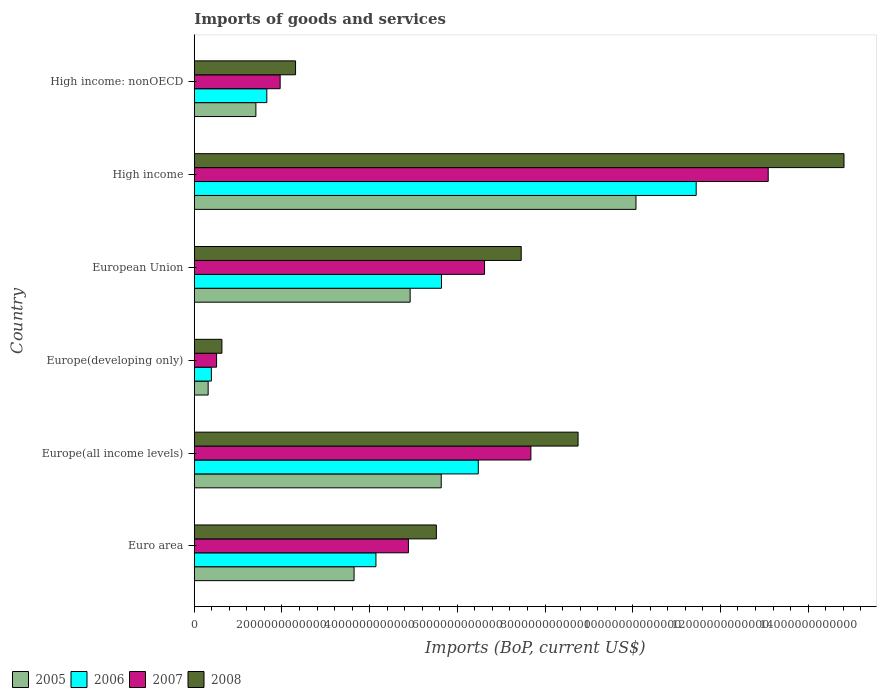Are the number of bars per tick equal to the number of legend labels?
Ensure brevity in your answer.  Yes. How many bars are there on the 1st tick from the top?
Provide a succinct answer. 4. What is the label of the 2nd group of bars from the top?
Offer a very short reply. High income. What is the amount spent on imports in 2007 in Europe(developing only)?
Offer a terse response. 5.09e+11. Across all countries, what is the maximum amount spent on imports in 2006?
Provide a short and direct response. 1.14e+13. Across all countries, what is the minimum amount spent on imports in 2006?
Offer a very short reply. 3.90e+11. In which country was the amount spent on imports in 2007 maximum?
Provide a succinct answer. High income. In which country was the amount spent on imports in 2008 minimum?
Provide a succinct answer. Europe(developing only). What is the total amount spent on imports in 2005 in the graph?
Your answer should be very brief. 2.60e+13. What is the difference between the amount spent on imports in 2006 in Euro area and that in Europe(all income levels)?
Ensure brevity in your answer.  -2.33e+12. What is the difference between the amount spent on imports in 2007 in Euro area and the amount spent on imports in 2008 in High income: nonOECD?
Keep it short and to the point. 2.57e+12. What is the average amount spent on imports in 2007 per country?
Offer a terse response. 5.79e+12. What is the difference between the amount spent on imports in 2005 and amount spent on imports in 2006 in Europe(all income levels)?
Your answer should be very brief. -8.45e+11. In how many countries, is the amount spent on imports in 2006 greater than 13200000000000 US$?
Give a very brief answer. 0. What is the ratio of the amount spent on imports in 2008 in Euro area to that in Europe(all income levels)?
Provide a short and direct response. 0.63. Is the difference between the amount spent on imports in 2005 in Europe(all income levels) and European Union greater than the difference between the amount spent on imports in 2006 in Europe(all income levels) and European Union?
Offer a very short reply. No. What is the difference between the highest and the second highest amount spent on imports in 2006?
Offer a very short reply. 4.97e+12. What is the difference between the highest and the lowest amount spent on imports in 2008?
Make the answer very short. 1.42e+13. In how many countries, is the amount spent on imports in 2007 greater than the average amount spent on imports in 2007 taken over all countries?
Provide a short and direct response. 3. Is the sum of the amount spent on imports in 2006 in Europe(all income levels) and High income greater than the maximum amount spent on imports in 2008 across all countries?
Provide a short and direct response. Yes. How many bars are there?
Offer a terse response. 24. What is the difference between two consecutive major ticks on the X-axis?
Offer a very short reply. 2.00e+12. Does the graph contain any zero values?
Keep it short and to the point. No. Where does the legend appear in the graph?
Provide a succinct answer. Bottom left. How many legend labels are there?
Keep it short and to the point. 4. How are the legend labels stacked?
Keep it short and to the point. Horizontal. What is the title of the graph?
Your answer should be very brief. Imports of goods and services. Does "2007" appear as one of the legend labels in the graph?
Provide a succinct answer. Yes. What is the label or title of the X-axis?
Provide a succinct answer. Imports (BoP, current US$). What is the Imports (BoP, current US$) in 2005 in Euro area?
Make the answer very short. 3.64e+12. What is the Imports (BoP, current US$) in 2006 in Euro area?
Give a very brief answer. 4.14e+12. What is the Imports (BoP, current US$) of 2007 in Euro area?
Your answer should be compact. 4.88e+12. What is the Imports (BoP, current US$) in 2008 in Euro area?
Offer a terse response. 5.52e+12. What is the Imports (BoP, current US$) of 2005 in Europe(all income levels)?
Offer a very short reply. 5.63e+12. What is the Imports (BoP, current US$) of 2006 in Europe(all income levels)?
Your answer should be very brief. 6.48e+12. What is the Imports (BoP, current US$) of 2007 in Europe(all income levels)?
Give a very brief answer. 7.68e+12. What is the Imports (BoP, current US$) in 2008 in Europe(all income levels)?
Your answer should be very brief. 8.75e+12. What is the Imports (BoP, current US$) of 2005 in Europe(developing only)?
Provide a short and direct response. 3.17e+11. What is the Imports (BoP, current US$) in 2006 in Europe(developing only)?
Provide a succinct answer. 3.90e+11. What is the Imports (BoP, current US$) in 2007 in Europe(developing only)?
Provide a short and direct response. 5.09e+11. What is the Imports (BoP, current US$) in 2008 in Europe(developing only)?
Keep it short and to the point. 6.31e+11. What is the Imports (BoP, current US$) in 2005 in European Union?
Keep it short and to the point. 4.92e+12. What is the Imports (BoP, current US$) of 2006 in European Union?
Give a very brief answer. 5.64e+12. What is the Imports (BoP, current US$) in 2007 in European Union?
Your answer should be very brief. 6.62e+12. What is the Imports (BoP, current US$) of 2008 in European Union?
Keep it short and to the point. 7.46e+12. What is the Imports (BoP, current US$) in 2005 in High income?
Make the answer very short. 1.01e+13. What is the Imports (BoP, current US$) in 2006 in High income?
Ensure brevity in your answer.  1.14e+13. What is the Imports (BoP, current US$) of 2007 in High income?
Your answer should be compact. 1.31e+13. What is the Imports (BoP, current US$) of 2008 in High income?
Offer a very short reply. 1.48e+13. What is the Imports (BoP, current US$) in 2005 in High income: nonOECD?
Provide a succinct answer. 1.41e+12. What is the Imports (BoP, current US$) of 2006 in High income: nonOECD?
Offer a very short reply. 1.65e+12. What is the Imports (BoP, current US$) in 2007 in High income: nonOECD?
Offer a very short reply. 1.96e+12. What is the Imports (BoP, current US$) in 2008 in High income: nonOECD?
Your answer should be very brief. 2.31e+12. Across all countries, what is the maximum Imports (BoP, current US$) in 2005?
Your answer should be very brief. 1.01e+13. Across all countries, what is the maximum Imports (BoP, current US$) of 2006?
Your response must be concise. 1.14e+13. Across all countries, what is the maximum Imports (BoP, current US$) of 2007?
Provide a succinct answer. 1.31e+13. Across all countries, what is the maximum Imports (BoP, current US$) of 2008?
Make the answer very short. 1.48e+13. Across all countries, what is the minimum Imports (BoP, current US$) in 2005?
Keep it short and to the point. 3.17e+11. Across all countries, what is the minimum Imports (BoP, current US$) of 2006?
Give a very brief answer. 3.90e+11. Across all countries, what is the minimum Imports (BoP, current US$) of 2007?
Offer a very short reply. 5.09e+11. Across all countries, what is the minimum Imports (BoP, current US$) in 2008?
Offer a very short reply. 6.31e+11. What is the total Imports (BoP, current US$) in 2005 in the graph?
Offer a terse response. 2.60e+13. What is the total Imports (BoP, current US$) in 2006 in the graph?
Ensure brevity in your answer.  2.97e+13. What is the total Imports (BoP, current US$) in 2007 in the graph?
Ensure brevity in your answer.  3.47e+13. What is the total Imports (BoP, current US$) in 2008 in the graph?
Give a very brief answer. 3.95e+13. What is the difference between the Imports (BoP, current US$) in 2005 in Euro area and that in Europe(all income levels)?
Your answer should be very brief. -1.99e+12. What is the difference between the Imports (BoP, current US$) in 2006 in Euro area and that in Europe(all income levels)?
Offer a terse response. -2.33e+12. What is the difference between the Imports (BoP, current US$) of 2007 in Euro area and that in Europe(all income levels)?
Provide a succinct answer. -2.79e+12. What is the difference between the Imports (BoP, current US$) of 2008 in Euro area and that in Europe(all income levels)?
Keep it short and to the point. -3.23e+12. What is the difference between the Imports (BoP, current US$) of 2005 in Euro area and that in Europe(developing only)?
Offer a very short reply. 3.33e+12. What is the difference between the Imports (BoP, current US$) of 2006 in Euro area and that in Europe(developing only)?
Keep it short and to the point. 3.75e+12. What is the difference between the Imports (BoP, current US$) of 2007 in Euro area and that in Europe(developing only)?
Your answer should be very brief. 4.38e+12. What is the difference between the Imports (BoP, current US$) in 2008 in Euro area and that in Europe(developing only)?
Provide a succinct answer. 4.89e+12. What is the difference between the Imports (BoP, current US$) of 2005 in Euro area and that in European Union?
Make the answer very short. -1.28e+12. What is the difference between the Imports (BoP, current US$) of 2006 in Euro area and that in European Union?
Your response must be concise. -1.49e+12. What is the difference between the Imports (BoP, current US$) in 2007 in Euro area and that in European Union?
Give a very brief answer. -1.74e+12. What is the difference between the Imports (BoP, current US$) in 2008 in Euro area and that in European Union?
Make the answer very short. -1.94e+12. What is the difference between the Imports (BoP, current US$) of 2005 in Euro area and that in High income?
Provide a succinct answer. -6.43e+12. What is the difference between the Imports (BoP, current US$) of 2006 in Euro area and that in High income?
Provide a short and direct response. -7.30e+12. What is the difference between the Imports (BoP, current US$) in 2007 in Euro area and that in High income?
Your answer should be very brief. -8.21e+12. What is the difference between the Imports (BoP, current US$) in 2008 in Euro area and that in High income?
Your answer should be very brief. -9.30e+12. What is the difference between the Imports (BoP, current US$) in 2005 in Euro area and that in High income: nonOECD?
Your response must be concise. 2.24e+12. What is the difference between the Imports (BoP, current US$) of 2006 in Euro area and that in High income: nonOECD?
Your response must be concise. 2.49e+12. What is the difference between the Imports (BoP, current US$) in 2007 in Euro area and that in High income: nonOECD?
Make the answer very short. 2.93e+12. What is the difference between the Imports (BoP, current US$) in 2008 in Euro area and that in High income: nonOECD?
Ensure brevity in your answer.  3.21e+12. What is the difference between the Imports (BoP, current US$) in 2005 in Europe(all income levels) and that in Europe(developing only)?
Your response must be concise. 5.32e+12. What is the difference between the Imports (BoP, current US$) in 2006 in Europe(all income levels) and that in Europe(developing only)?
Ensure brevity in your answer.  6.09e+12. What is the difference between the Imports (BoP, current US$) in 2007 in Europe(all income levels) and that in Europe(developing only)?
Offer a terse response. 7.17e+12. What is the difference between the Imports (BoP, current US$) of 2008 in Europe(all income levels) and that in Europe(developing only)?
Offer a very short reply. 8.12e+12. What is the difference between the Imports (BoP, current US$) of 2005 in Europe(all income levels) and that in European Union?
Offer a very short reply. 7.09e+11. What is the difference between the Imports (BoP, current US$) of 2006 in Europe(all income levels) and that in European Union?
Your answer should be compact. 8.39e+11. What is the difference between the Imports (BoP, current US$) of 2007 in Europe(all income levels) and that in European Union?
Provide a succinct answer. 1.06e+12. What is the difference between the Imports (BoP, current US$) of 2008 in Europe(all income levels) and that in European Union?
Offer a very short reply. 1.30e+12. What is the difference between the Imports (BoP, current US$) of 2005 in Europe(all income levels) and that in High income?
Provide a succinct answer. -4.44e+12. What is the difference between the Imports (BoP, current US$) of 2006 in Europe(all income levels) and that in High income?
Offer a terse response. -4.97e+12. What is the difference between the Imports (BoP, current US$) in 2007 in Europe(all income levels) and that in High income?
Keep it short and to the point. -5.41e+12. What is the difference between the Imports (BoP, current US$) in 2008 in Europe(all income levels) and that in High income?
Provide a succinct answer. -6.06e+12. What is the difference between the Imports (BoP, current US$) of 2005 in Europe(all income levels) and that in High income: nonOECD?
Offer a terse response. 4.23e+12. What is the difference between the Imports (BoP, current US$) of 2006 in Europe(all income levels) and that in High income: nonOECD?
Ensure brevity in your answer.  4.82e+12. What is the difference between the Imports (BoP, current US$) of 2007 in Europe(all income levels) and that in High income: nonOECD?
Offer a terse response. 5.72e+12. What is the difference between the Imports (BoP, current US$) in 2008 in Europe(all income levels) and that in High income: nonOECD?
Make the answer very short. 6.44e+12. What is the difference between the Imports (BoP, current US$) of 2005 in Europe(developing only) and that in European Union?
Your answer should be very brief. -4.61e+12. What is the difference between the Imports (BoP, current US$) of 2006 in Europe(developing only) and that in European Union?
Your response must be concise. -5.25e+12. What is the difference between the Imports (BoP, current US$) in 2007 in Europe(developing only) and that in European Union?
Ensure brevity in your answer.  -6.11e+12. What is the difference between the Imports (BoP, current US$) in 2008 in Europe(developing only) and that in European Union?
Make the answer very short. -6.83e+12. What is the difference between the Imports (BoP, current US$) in 2005 in Europe(developing only) and that in High income?
Your answer should be very brief. -9.76e+12. What is the difference between the Imports (BoP, current US$) of 2006 in Europe(developing only) and that in High income?
Your answer should be very brief. -1.11e+13. What is the difference between the Imports (BoP, current US$) in 2007 in Europe(developing only) and that in High income?
Make the answer very short. -1.26e+13. What is the difference between the Imports (BoP, current US$) in 2008 in Europe(developing only) and that in High income?
Provide a short and direct response. -1.42e+13. What is the difference between the Imports (BoP, current US$) of 2005 in Europe(developing only) and that in High income: nonOECD?
Your answer should be very brief. -1.09e+12. What is the difference between the Imports (BoP, current US$) of 2006 in Europe(developing only) and that in High income: nonOECD?
Keep it short and to the point. -1.26e+12. What is the difference between the Imports (BoP, current US$) of 2007 in Europe(developing only) and that in High income: nonOECD?
Provide a short and direct response. -1.45e+12. What is the difference between the Imports (BoP, current US$) in 2008 in Europe(developing only) and that in High income: nonOECD?
Ensure brevity in your answer.  -1.68e+12. What is the difference between the Imports (BoP, current US$) of 2005 in European Union and that in High income?
Your answer should be very brief. -5.15e+12. What is the difference between the Imports (BoP, current US$) in 2006 in European Union and that in High income?
Offer a terse response. -5.81e+12. What is the difference between the Imports (BoP, current US$) of 2007 in European Union and that in High income?
Provide a succinct answer. -6.47e+12. What is the difference between the Imports (BoP, current US$) of 2008 in European Union and that in High income?
Offer a terse response. -7.36e+12. What is the difference between the Imports (BoP, current US$) of 2005 in European Union and that in High income: nonOECD?
Offer a terse response. 3.52e+12. What is the difference between the Imports (BoP, current US$) of 2006 in European Union and that in High income: nonOECD?
Make the answer very short. 3.98e+12. What is the difference between the Imports (BoP, current US$) in 2007 in European Union and that in High income: nonOECD?
Make the answer very short. 4.66e+12. What is the difference between the Imports (BoP, current US$) of 2008 in European Union and that in High income: nonOECD?
Keep it short and to the point. 5.15e+12. What is the difference between the Imports (BoP, current US$) of 2005 in High income and that in High income: nonOECD?
Your response must be concise. 8.67e+12. What is the difference between the Imports (BoP, current US$) of 2006 in High income and that in High income: nonOECD?
Ensure brevity in your answer.  9.79e+12. What is the difference between the Imports (BoP, current US$) in 2007 in High income and that in High income: nonOECD?
Your response must be concise. 1.11e+13. What is the difference between the Imports (BoP, current US$) in 2008 in High income and that in High income: nonOECD?
Offer a terse response. 1.25e+13. What is the difference between the Imports (BoP, current US$) of 2005 in Euro area and the Imports (BoP, current US$) of 2006 in Europe(all income levels)?
Give a very brief answer. -2.83e+12. What is the difference between the Imports (BoP, current US$) of 2005 in Euro area and the Imports (BoP, current US$) of 2007 in Europe(all income levels)?
Make the answer very short. -4.03e+12. What is the difference between the Imports (BoP, current US$) of 2005 in Euro area and the Imports (BoP, current US$) of 2008 in Europe(all income levels)?
Your response must be concise. -5.11e+12. What is the difference between the Imports (BoP, current US$) of 2006 in Euro area and the Imports (BoP, current US$) of 2007 in Europe(all income levels)?
Give a very brief answer. -3.53e+12. What is the difference between the Imports (BoP, current US$) of 2006 in Euro area and the Imports (BoP, current US$) of 2008 in Europe(all income levels)?
Offer a very short reply. -4.61e+12. What is the difference between the Imports (BoP, current US$) of 2007 in Euro area and the Imports (BoP, current US$) of 2008 in Europe(all income levels)?
Offer a very short reply. -3.87e+12. What is the difference between the Imports (BoP, current US$) in 2005 in Euro area and the Imports (BoP, current US$) in 2006 in Europe(developing only)?
Keep it short and to the point. 3.25e+12. What is the difference between the Imports (BoP, current US$) of 2005 in Euro area and the Imports (BoP, current US$) of 2007 in Europe(developing only)?
Ensure brevity in your answer.  3.14e+12. What is the difference between the Imports (BoP, current US$) of 2005 in Euro area and the Imports (BoP, current US$) of 2008 in Europe(developing only)?
Give a very brief answer. 3.01e+12. What is the difference between the Imports (BoP, current US$) of 2006 in Euro area and the Imports (BoP, current US$) of 2007 in Europe(developing only)?
Your answer should be compact. 3.63e+12. What is the difference between the Imports (BoP, current US$) of 2006 in Euro area and the Imports (BoP, current US$) of 2008 in Europe(developing only)?
Provide a succinct answer. 3.51e+12. What is the difference between the Imports (BoP, current US$) in 2007 in Euro area and the Imports (BoP, current US$) in 2008 in Europe(developing only)?
Provide a short and direct response. 4.25e+12. What is the difference between the Imports (BoP, current US$) of 2005 in Euro area and the Imports (BoP, current US$) of 2006 in European Union?
Make the answer very short. -1.99e+12. What is the difference between the Imports (BoP, current US$) in 2005 in Euro area and the Imports (BoP, current US$) in 2007 in European Union?
Make the answer very short. -2.98e+12. What is the difference between the Imports (BoP, current US$) of 2005 in Euro area and the Imports (BoP, current US$) of 2008 in European Union?
Make the answer very short. -3.81e+12. What is the difference between the Imports (BoP, current US$) of 2006 in Euro area and the Imports (BoP, current US$) of 2007 in European Union?
Make the answer very short. -2.48e+12. What is the difference between the Imports (BoP, current US$) in 2006 in Euro area and the Imports (BoP, current US$) in 2008 in European Union?
Make the answer very short. -3.31e+12. What is the difference between the Imports (BoP, current US$) of 2007 in Euro area and the Imports (BoP, current US$) of 2008 in European Union?
Your answer should be compact. -2.57e+12. What is the difference between the Imports (BoP, current US$) in 2005 in Euro area and the Imports (BoP, current US$) in 2006 in High income?
Offer a very short reply. -7.80e+12. What is the difference between the Imports (BoP, current US$) of 2005 in Euro area and the Imports (BoP, current US$) of 2007 in High income?
Offer a very short reply. -9.44e+12. What is the difference between the Imports (BoP, current US$) in 2005 in Euro area and the Imports (BoP, current US$) in 2008 in High income?
Offer a very short reply. -1.12e+13. What is the difference between the Imports (BoP, current US$) of 2006 in Euro area and the Imports (BoP, current US$) of 2007 in High income?
Provide a succinct answer. -8.95e+12. What is the difference between the Imports (BoP, current US$) in 2006 in Euro area and the Imports (BoP, current US$) in 2008 in High income?
Offer a very short reply. -1.07e+13. What is the difference between the Imports (BoP, current US$) in 2007 in Euro area and the Imports (BoP, current US$) in 2008 in High income?
Provide a succinct answer. -9.93e+12. What is the difference between the Imports (BoP, current US$) in 2005 in Euro area and the Imports (BoP, current US$) in 2006 in High income: nonOECD?
Offer a very short reply. 1.99e+12. What is the difference between the Imports (BoP, current US$) of 2005 in Euro area and the Imports (BoP, current US$) of 2007 in High income: nonOECD?
Your answer should be very brief. 1.69e+12. What is the difference between the Imports (BoP, current US$) of 2005 in Euro area and the Imports (BoP, current US$) of 2008 in High income: nonOECD?
Give a very brief answer. 1.33e+12. What is the difference between the Imports (BoP, current US$) in 2006 in Euro area and the Imports (BoP, current US$) in 2007 in High income: nonOECD?
Offer a very short reply. 2.18e+12. What is the difference between the Imports (BoP, current US$) in 2006 in Euro area and the Imports (BoP, current US$) in 2008 in High income: nonOECD?
Offer a terse response. 1.83e+12. What is the difference between the Imports (BoP, current US$) in 2007 in Euro area and the Imports (BoP, current US$) in 2008 in High income: nonOECD?
Ensure brevity in your answer.  2.57e+12. What is the difference between the Imports (BoP, current US$) of 2005 in Europe(all income levels) and the Imports (BoP, current US$) of 2006 in Europe(developing only)?
Give a very brief answer. 5.24e+12. What is the difference between the Imports (BoP, current US$) in 2005 in Europe(all income levels) and the Imports (BoP, current US$) in 2007 in Europe(developing only)?
Make the answer very short. 5.12e+12. What is the difference between the Imports (BoP, current US$) in 2005 in Europe(all income levels) and the Imports (BoP, current US$) in 2008 in Europe(developing only)?
Ensure brevity in your answer.  5.00e+12. What is the difference between the Imports (BoP, current US$) of 2006 in Europe(all income levels) and the Imports (BoP, current US$) of 2007 in Europe(developing only)?
Keep it short and to the point. 5.97e+12. What is the difference between the Imports (BoP, current US$) in 2006 in Europe(all income levels) and the Imports (BoP, current US$) in 2008 in Europe(developing only)?
Your response must be concise. 5.85e+12. What is the difference between the Imports (BoP, current US$) of 2007 in Europe(all income levels) and the Imports (BoP, current US$) of 2008 in Europe(developing only)?
Your answer should be compact. 7.05e+12. What is the difference between the Imports (BoP, current US$) in 2005 in Europe(all income levels) and the Imports (BoP, current US$) in 2006 in European Union?
Offer a terse response. -5.36e+09. What is the difference between the Imports (BoP, current US$) in 2005 in Europe(all income levels) and the Imports (BoP, current US$) in 2007 in European Union?
Make the answer very short. -9.88e+11. What is the difference between the Imports (BoP, current US$) in 2005 in Europe(all income levels) and the Imports (BoP, current US$) in 2008 in European Union?
Give a very brief answer. -1.82e+12. What is the difference between the Imports (BoP, current US$) in 2006 in Europe(all income levels) and the Imports (BoP, current US$) in 2007 in European Union?
Give a very brief answer. -1.43e+11. What is the difference between the Imports (BoP, current US$) in 2006 in Europe(all income levels) and the Imports (BoP, current US$) in 2008 in European Union?
Your answer should be very brief. -9.79e+11. What is the difference between the Imports (BoP, current US$) in 2007 in Europe(all income levels) and the Imports (BoP, current US$) in 2008 in European Union?
Keep it short and to the point. 2.20e+11. What is the difference between the Imports (BoP, current US$) in 2005 in Europe(all income levels) and the Imports (BoP, current US$) in 2006 in High income?
Offer a terse response. -5.81e+12. What is the difference between the Imports (BoP, current US$) of 2005 in Europe(all income levels) and the Imports (BoP, current US$) of 2007 in High income?
Give a very brief answer. -7.46e+12. What is the difference between the Imports (BoP, current US$) of 2005 in Europe(all income levels) and the Imports (BoP, current US$) of 2008 in High income?
Your answer should be compact. -9.19e+12. What is the difference between the Imports (BoP, current US$) of 2006 in Europe(all income levels) and the Imports (BoP, current US$) of 2007 in High income?
Ensure brevity in your answer.  -6.61e+12. What is the difference between the Imports (BoP, current US$) in 2006 in Europe(all income levels) and the Imports (BoP, current US$) in 2008 in High income?
Your answer should be compact. -8.34e+12. What is the difference between the Imports (BoP, current US$) of 2007 in Europe(all income levels) and the Imports (BoP, current US$) of 2008 in High income?
Keep it short and to the point. -7.14e+12. What is the difference between the Imports (BoP, current US$) of 2005 in Europe(all income levels) and the Imports (BoP, current US$) of 2006 in High income: nonOECD?
Your answer should be very brief. 3.98e+12. What is the difference between the Imports (BoP, current US$) of 2005 in Europe(all income levels) and the Imports (BoP, current US$) of 2007 in High income: nonOECD?
Your response must be concise. 3.67e+12. What is the difference between the Imports (BoP, current US$) in 2005 in Europe(all income levels) and the Imports (BoP, current US$) in 2008 in High income: nonOECD?
Your answer should be very brief. 3.32e+12. What is the difference between the Imports (BoP, current US$) of 2006 in Europe(all income levels) and the Imports (BoP, current US$) of 2007 in High income: nonOECD?
Keep it short and to the point. 4.52e+12. What is the difference between the Imports (BoP, current US$) of 2006 in Europe(all income levels) and the Imports (BoP, current US$) of 2008 in High income: nonOECD?
Your answer should be compact. 4.17e+12. What is the difference between the Imports (BoP, current US$) of 2007 in Europe(all income levels) and the Imports (BoP, current US$) of 2008 in High income: nonOECD?
Provide a succinct answer. 5.37e+12. What is the difference between the Imports (BoP, current US$) of 2005 in Europe(developing only) and the Imports (BoP, current US$) of 2006 in European Union?
Provide a succinct answer. -5.32e+12. What is the difference between the Imports (BoP, current US$) in 2005 in Europe(developing only) and the Imports (BoP, current US$) in 2007 in European Union?
Provide a short and direct response. -6.30e+12. What is the difference between the Imports (BoP, current US$) of 2005 in Europe(developing only) and the Imports (BoP, current US$) of 2008 in European Union?
Keep it short and to the point. -7.14e+12. What is the difference between the Imports (BoP, current US$) of 2006 in Europe(developing only) and the Imports (BoP, current US$) of 2007 in European Union?
Offer a very short reply. -6.23e+12. What is the difference between the Imports (BoP, current US$) in 2006 in Europe(developing only) and the Imports (BoP, current US$) in 2008 in European Union?
Ensure brevity in your answer.  -7.07e+12. What is the difference between the Imports (BoP, current US$) of 2007 in Europe(developing only) and the Imports (BoP, current US$) of 2008 in European Union?
Give a very brief answer. -6.95e+12. What is the difference between the Imports (BoP, current US$) in 2005 in Europe(developing only) and the Imports (BoP, current US$) in 2006 in High income?
Your answer should be very brief. -1.11e+13. What is the difference between the Imports (BoP, current US$) in 2005 in Europe(developing only) and the Imports (BoP, current US$) in 2007 in High income?
Your answer should be very brief. -1.28e+13. What is the difference between the Imports (BoP, current US$) in 2005 in Europe(developing only) and the Imports (BoP, current US$) in 2008 in High income?
Offer a very short reply. -1.45e+13. What is the difference between the Imports (BoP, current US$) in 2006 in Europe(developing only) and the Imports (BoP, current US$) in 2007 in High income?
Offer a terse response. -1.27e+13. What is the difference between the Imports (BoP, current US$) in 2006 in Europe(developing only) and the Imports (BoP, current US$) in 2008 in High income?
Your answer should be compact. -1.44e+13. What is the difference between the Imports (BoP, current US$) in 2007 in Europe(developing only) and the Imports (BoP, current US$) in 2008 in High income?
Your answer should be very brief. -1.43e+13. What is the difference between the Imports (BoP, current US$) of 2005 in Europe(developing only) and the Imports (BoP, current US$) of 2006 in High income: nonOECD?
Offer a terse response. -1.34e+12. What is the difference between the Imports (BoP, current US$) in 2005 in Europe(developing only) and the Imports (BoP, current US$) in 2007 in High income: nonOECD?
Your answer should be very brief. -1.64e+12. What is the difference between the Imports (BoP, current US$) in 2005 in Europe(developing only) and the Imports (BoP, current US$) in 2008 in High income: nonOECD?
Make the answer very short. -1.99e+12. What is the difference between the Imports (BoP, current US$) of 2006 in Europe(developing only) and the Imports (BoP, current US$) of 2007 in High income: nonOECD?
Provide a short and direct response. -1.57e+12. What is the difference between the Imports (BoP, current US$) of 2006 in Europe(developing only) and the Imports (BoP, current US$) of 2008 in High income: nonOECD?
Ensure brevity in your answer.  -1.92e+12. What is the difference between the Imports (BoP, current US$) of 2007 in Europe(developing only) and the Imports (BoP, current US$) of 2008 in High income: nonOECD?
Ensure brevity in your answer.  -1.80e+12. What is the difference between the Imports (BoP, current US$) in 2005 in European Union and the Imports (BoP, current US$) in 2006 in High income?
Your answer should be very brief. -6.52e+12. What is the difference between the Imports (BoP, current US$) of 2005 in European Union and the Imports (BoP, current US$) of 2007 in High income?
Your response must be concise. -8.17e+12. What is the difference between the Imports (BoP, current US$) of 2005 in European Union and the Imports (BoP, current US$) of 2008 in High income?
Your answer should be compact. -9.89e+12. What is the difference between the Imports (BoP, current US$) of 2006 in European Union and the Imports (BoP, current US$) of 2007 in High income?
Your answer should be very brief. -7.45e+12. What is the difference between the Imports (BoP, current US$) in 2006 in European Union and the Imports (BoP, current US$) in 2008 in High income?
Offer a terse response. -9.18e+12. What is the difference between the Imports (BoP, current US$) of 2007 in European Union and the Imports (BoP, current US$) of 2008 in High income?
Your answer should be compact. -8.20e+12. What is the difference between the Imports (BoP, current US$) of 2005 in European Union and the Imports (BoP, current US$) of 2006 in High income: nonOECD?
Offer a very short reply. 3.27e+12. What is the difference between the Imports (BoP, current US$) in 2005 in European Union and the Imports (BoP, current US$) in 2007 in High income: nonOECD?
Keep it short and to the point. 2.96e+12. What is the difference between the Imports (BoP, current US$) of 2005 in European Union and the Imports (BoP, current US$) of 2008 in High income: nonOECD?
Your answer should be compact. 2.61e+12. What is the difference between the Imports (BoP, current US$) of 2006 in European Union and the Imports (BoP, current US$) of 2007 in High income: nonOECD?
Provide a succinct answer. 3.68e+12. What is the difference between the Imports (BoP, current US$) of 2006 in European Union and the Imports (BoP, current US$) of 2008 in High income: nonOECD?
Offer a terse response. 3.33e+12. What is the difference between the Imports (BoP, current US$) of 2007 in European Union and the Imports (BoP, current US$) of 2008 in High income: nonOECD?
Offer a very short reply. 4.31e+12. What is the difference between the Imports (BoP, current US$) in 2005 in High income and the Imports (BoP, current US$) in 2006 in High income: nonOECD?
Your response must be concise. 8.42e+12. What is the difference between the Imports (BoP, current US$) of 2005 in High income and the Imports (BoP, current US$) of 2007 in High income: nonOECD?
Provide a short and direct response. 8.11e+12. What is the difference between the Imports (BoP, current US$) in 2005 in High income and the Imports (BoP, current US$) in 2008 in High income: nonOECD?
Your answer should be compact. 7.76e+12. What is the difference between the Imports (BoP, current US$) of 2006 in High income and the Imports (BoP, current US$) of 2007 in High income: nonOECD?
Make the answer very short. 9.49e+12. What is the difference between the Imports (BoP, current US$) in 2006 in High income and the Imports (BoP, current US$) in 2008 in High income: nonOECD?
Offer a very short reply. 9.14e+12. What is the difference between the Imports (BoP, current US$) of 2007 in High income and the Imports (BoP, current US$) of 2008 in High income: nonOECD?
Offer a terse response. 1.08e+13. What is the average Imports (BoP, current US$) in 2005 per country?
Offer a terse response. 4.33e+12. What is the average Imports (BoP, current US$) of 2006 per country?
Give a very brief answer. 4.96e+12. What is the average Imports (BoP, current US$) of 2007 per country?
Keep it short and to the point. 5.79e+12. What is the average Imports (BoP, current US$) of 2008 per country?
Provide a succinct answer. 6.58e+12. What is the difference between the Imports (BoP, current US$) of 2005 and Imports (BoP, current US$) of 2006 in Euro area?
Provide a short and direct response. -4.99e+11. What is the difference between the Imports (BoP, current US$) of 2005 and Imports (BoP, current US$) of 2007 in Euro area?
Provide a short and direct response. -1.24e+12. What is the difference between the Imports (BoP, current US$) in 2005 and Imports (BoP, current US$) in 2008 in Euro area?
Offer a terse response. -1.88e+12. What is the difference between the Imports (BoP, current US$) of 2006 and Imports (BoP, current US$) of 2007 in Euro area?
Give a very brief answer. -7.41e+11. What is the difference between the Imports (BoP, current US$) in 2006 and Imports (BoP, current US$) in 2008 in Euro area?
Offer a very short reply. -1.38e+12. What is the difference between the Imports (BoP, current US$) in 2007 and Imports (BoP, current US$) in 2008 in Euro area?
Offer a terse response. -6.37e+11. What is the difference between the Imports (BoP, current US$) in 2005 and Imports (BoP, current US$) in 2006 in Europe(all income levels)?
Ensure brevity in your answer.  -8.45e+11. What is the difference between the Imports (BoP, current US$) of 2005 and Imports (BoP, current US$) of 2007 in Europe(all income levels)?
Offer a terse response. -2.04e+12. What is the difference between the Imports (BoP, current US$) of 2005 and Imports (BoP, current US$) of 2008 in Europe(all income levels)?
Your response must be concise. -3.12e+12. What is the difference between the Imports (BoP, current US$) in 2006 and Imports (BoP, current US$) in 2007 in Europe(all income levels)?
Provide a short and direct response. -1.20e+12. What is the difference between the Imports (BoP, current US$) in 2006 and Imports (BoP, current US$) in 2008 in Europe(all income levels)?
Offer a very short reply. -2.28e+12. What is the difference between the Imports (BoP, current US$) of 2007 and Imports (BoP, current US$) of 2008 in Europe(all income levels)?
Offer a very short reply. -1.08e+12. What is the difference between the Imports (BoP, current US$) of 2005 and Imports (BoP, current US$) of 2006 in Europe(developing only)?
Provide a short and direct response. -7.33e+1. What is the difference between the Imports (BoP, current US$) of 2005 and Imports (BoP, current US$) of 2007 in Europe(developing only)?
Provide a short and direct response. -1.92e+11. What is the difference between the Imports (BoP, current US$) of 2005 and Imports (BoP, current US$) of 2008 in Europe(developing only)?
Your answer should be very brief. -3.14e+11. What is the difference between the Imports (BoP, current US$) of 2006 and Imports (BoP, current US$) of 2007 in Europe(developing only)?
Provide a short and direct response. -1.18e+11. What is the difference between the Imports (BoP, current US$) in 2006 and Imports (BoP, current US$) in 2008 in Europe(developing only)?
Your response must be concise. -2.40e+11. What is the difference between the Imports (BoP, current US$) of 2007 and Imports (BoP, current US$) of 2008 in Europe(developing only)?
Ensure brevity in your answer.  -1.22e+11. What is the difference between the Imports (BoP, current US$) in 2005 and Imports (BoP, current US$) in 2006 in European Union?
Give a very brief answer. -7.15e+11. What is the difference between the Imports (BoP, current US$) in 2005 and Imports (BoP, current US$) in 2007 in European Union?
Offer a very short reply. -1.70e+12. What is the difference between the Imports (BoP, current US$) of 2005 and Imports (BoP, current US$) of 2008 in European Union?
Offer a very short reply. -2.53e+12. What is the difference between the Imports (BoP, current US$) in 2006 and Imports (BoP, current US$) in 2007 in European Union?
Provide a short and direct response. -9.82e+11. What is the difference between the Imports (BoP, current US$) of 2006 and Imports (BoP, current US$) of 2008 in European Union?
Provide a short and direct response. -1.82e+12. What is the difference between the Imports (BoP, current US$) of 2007 and Imports (BoP, current US$) of 2008 in European Union?
Offer a very short reply. -8.37e+11. What is the difference between the Imports (BoP, current US$) of 2005 and Imports (BoP, current US$) of 2006 in High income?
Your answer should be very brief. -1.37e+12. What is the difference between the Imports (BoP, current US$) of 2005 and Imports (BoP, current US$) of 2007 in High income?
Provide a short and direct response. -3.02e+12. What is the difference between the Imports (BoP, current US$) of 2005 and Imports (BoP, current US$) of 2008 in High income?
Your response must be concise. -4.74e+12. What is the difference between the Imports (BoP, current US$) of 2006 and Imports (BoP, current US$) of 2007 in High income?
Ensure brevity in your answer.  -1.64e+12. What is the difference between the Imports (BoP, current US$) of 2006 and Imports (BoP, current US$) of 2008 in High income?
Provide a short and direct response. -3.37e+12. What is the difference between the Imports (BoP, current US$) of 2007 and Imports (BoP, current US$) of 2008 in High income?
Your answer should be very brief. -1.73e+12. What is the difference between the Imports (BoP, current US$) in 2005 and Imports (BoP, current US$) in 2006 in High income: nonOECD?
Give a very brief answer. -2.49e+11. What is the difference between the Imports (BoP, current US$) of 2005 and Imports (BoP, current US$) of 2007 in High income: nonOECD?
Offer a terse response. -5.53e+11. What is the difference between the Imports (BoP, current US$) of 2005 and Imports (BoP, current US$) of 2008 in High income: nonOECD?
Make the answer very short. -9.05e+11. What is the difference between the Imports (BoP, current US$) in 2006 and Imports (BoP, current US$) in 2007 in High income: nonOECD?
Your answer should be very brief. -3.04e+11. What is the difference between the Imports (BoP, current US$) of 2006 and Imports (BoP, current US$) of 2008 in High income: nonOECD?
Make the answer very short. -6.56e+11. What is the difference between the Imports (BoP, current US$) of 2007 and Imports (BoP, current US$) of 2008 in High income: nonOECD?
Ensure brevity in your answer.  -3.51e+11. What is the ratio of the Imports (BoP, current US$) in 2005 in Euro area to that in Europe(all income levels)?
Make the answer very short. 0.65. What is the ratio of the Imports (BoP, current US$) in 2006 in Euro area to that in Europe(all income levels)?
Offer a very short reply. 0.64. What is the ratio of the Imports (BoP, current US$) in 2007 in Euro area to that in Europe(all income levels)?
Your response must be concise. 0.64. What is the ratio of the Imports (BoP, current US$) in 2008 in Euro area to that in Europe(all income levels)?
Keep it short and to the point. 0.63. What is the ratio of the Imports (BoP, current US$) in 2005 in Euro area to that in Europe(developing only)?
Offer a very short reply. 11.5. What is the ratio of the Imports (BoP, current US$) of 2006 in Euro area to that in Europe(developing only)?
Give a very brief answer. 10.62. What is the ratio of the Imports (BoP, current US$) of 2007 in Euro area to that in Europe(developing only)?
Offer a terse response. 9.6. What is the ratio of the Imports (BoP, current US$) of 2008 in Euro area to that in Europe(developing only)?
Give a very brief answer. 8.76. What is the ratio of the Imports (BoP, current US$) in 2005 in Euro area to that in European Union?
Make the answer very short. 0.74. What is the ratio of the Imports (BoP, current US$) of 2006 in Euro area to that in European Union?
Provide a short and direct response. 0.73. What is the ratio of the Imports (BoP, current US$) in 2007 in Euro area to that in European Union?
Your answer should be very brief. 0.74. What is the ratio of the Imports (BoP, current US$) of 2008 in Euro area to that in European Union?
Provide a short and direct response. 0.74. What is the ratio of the Imports (BoP, current US$) of 2005 in Euro area to that in High income?
Your answer should be compact. 0.36. What is the ratio of the Imports (BoP, current US$) in 2006 in Euro area to that in High income?
Your answer should be very brief. 0.36. What is the ratio of the Imports (BoP, current US$) of 2007 in Euro area to that in High income?
Offer a very short reply. 0.37. What is the ratio of the Imports (BoP, current US$) in 2008 in Euro area to that in High income?
Your answer should be compact. 0.37. What is the ratio of the Imports (BoP, current US$) in 2005 in Euro area to that in High income: nonOECD?
Your answer should be very brief. 2.59. What is the ratio of the Imports (BoP, current US$) of 2006 in Euro area to that in High income: nonOECD?
Provide a short and direct response. 2.5. What is the ratio of the Imports (BoP, current US$) of 2007 in Euro area to that in High income: nonOECD?
Offer a very short reply. 2.49. What is the ratio of the Imports (BoP, current US$) in 2008 in Euro area to that in High income: nonOECD?
Offer a terse response. 2.39. What is the ratio of the Imports (BoP, current US$) in 2005 in Europe(all income levels) to that in Europe(developing only)?
Offer a very short reply. 17.77. What is the ratio of the Imports (BoP, current US$) in 2006 in Europe(all income levels) to that in Europe(developing only)?
Your response must be concise. 16.6. What is the ratio of the Imports (BoP, current US$) in 2007 in Europe(all income levels) to that in Europe(developing only)?
Offer a very short reply. 15.09. What is the ratio of the Imports (BoP, current US$) in 2008 in Europe(all income levels) to that in Europe(developing only)?
Provide a succinct answer. 13.88. What is the ratio of the Imports (BoP, current US$) of 2005 in Europe(all income levels) to that in European Union?
Offer a very short reply. 1.14. What is the ratio of the Imports (BoP, current US$) in 2006 in Europe(all income levels) to that in European Union?
Your answer should be very brief. 1.15. What is the ratio of the Imports (BoP, current US$) in 2007 in Europe(all income levels) to that in European Union?
Offer a terse response. 1.16. What is the ratio of the Imports (BoP, current US$) of 2008 in Europe(all income levels) to that in European Union?
Offer a very short reply. 1.17. What is the ratio of the Imports (BoP, current US$) in 2005 in Europe(all income levels) to that in High income?
Your response must be concise. 0.56. What is the ratio of the Imports (BoP, current US$) of 2006 in Europe(all income levels) to that in High income?
Offer a very short reply. 0.57. What is the ratio of the Imports (BoP, current US$) of 2007 in Europe(all income levels) to that in High income?
Ensure brevity in your answer.  0.59. What is the ratio of the Imports (BoP, current US$) in 2008 in Europe(all income levels) to that in High income?
Keep it short and to the point. 0.59. What is the ratio of the Imports (BoP, current US$) of 2005 in Europe(all income levels) to that in High income: nonOECD?
Your response must be concise. 4.01. What is the ratio of the Imports (BoP, current US$) in 2006 in Europe(all income levels) to that in High income: nonOECD?
Make the answer very short. 3.92. What is the ratio of the Imports (BoP, current US$) in 2007 in Europe(all income levels) to that in High income: nonOECD?
Your answer should be very brief. 3.92. What is the ratio of the Imports (BoP, current US$) in 2008 in Europe(all income levels) to that in High income: nonOECD?
Make the answer very short. 3.79. What is the ratio of the Imports (BoP, current US$) of 2005 in Europe(developing only) to that in European Union?
Your response must be concise. 0.06. What is the ratio of the Imports (BoP, current US$) in 2006 in Europe(developing only) to that in European Union?
Provide a short and direct response. 0.07. What is the ratio of the Imports (BoP, current US$) of 2007 in Europe(developing only) to that in European Union?
Your answer should be very brief. 0.08. What is the ratio of the Imports (BoP, current US$) in 2008 in Europe(developing only) to that in European Union?
Ensure brevity in your answer.  0.08. What is the ratio of the Imports (BoP, current US$) of 2005 in Europe(developing only) to that in High income?
Your response must be concise. 0.03. What is the ratio of the Imports (BoP, current US$) in 2006 in Europe(developing only) to that in High income?
Give a very brief answer. 0.03. What is the ratio of the Imports (BoP, current US$) in 2007 in Europe(developing only) to that in High income?
Ensure brevity in your answer.  0.04. What is the ratio of the Imports (BoP, current US$) in 2008 in Europe(developing only) to that in High income?
Your answer should be very brief. 0.04. What is the ratio of the Imports (BoP, current US$) of 2005 in Europe(developing only) to that in High income: nonOECD?
Ensure brevity in your answer.  0.23. What is the ratio of the Imports (BoP, current US$) of 2006 in Europe(developing only) to that in High income: nonOECD?
Offer a very short reply. 0.24. What is the ratio of the Imports (BoP, current US$) in 2007 in Europe(developing only) to that in High income: nonOECD?
Offer a very short reply. 0.26. What is the ratio of the Imports (BoP, current US$) in 2008 in Europe(developing only) to that in High income: nonOECD?
Make the answer very short. 0.27. What is the ratio of the Imports (BoP, current US$) of 2005 in European Union to that in High income?
Make the answer very short. 0.49. What is the ratio of the Imports (BoP, current US$) of 2006 in European Union to that in High income?
Ensure brevity in your answer.  0.49. What is the ratio of the Imports (BoP, current US$) of 2007 in European Union to that in High income?
Provide a succinct answer. 0.51. What is the ratio of the Imports (BoP, current US$) of 2008 in European Union to that in High income?
Provide a succinct answer. 0.5. What is the ratio of the Imports (BoP, current US$) of 2005 in European Union to that in High income: nonOECD?
Provide a succinct answer. 3.5. What is the ratio of the Imports (BoP, current US$) in 2006 in European Union to that in High income: nonOECD?
Offer a very short reply. 3.41. What is the ratio of the Imports (BoP, current US$) of 2007 in European Union to that in High income: nonOECD?
Keep it short and to the point. 3.38. What is the ratio of the Imports (BoP, current US$) in 2008 in European Union to that in High income: nonOECD?
Your response must be concise. 3.23. What is the ratio of the Imports (BoP, current US$) of 2005 in High income to that in High income: nonOECD?
Make the answer very short. 7.17. What is the ratio of the Imports (BoP, current US$) of 2006 in High income to that in High income: nonOECD?
Offer a very short reply. 6.92. What is the ratio of the Imports (BoP, current US$) in 2007 in High income to that in High income: nonOECD?
Give a very brief answer. 6.68. What is the ratio of the Imports (BoP, current US$) of 2008 in High income to that in High income: nonOECD?
Your response must be concise. 6.41. What is the difference between the highest and the second highest Imports (BoP, current US$) in 2005?
Your response must be concise. 4.44e+12. What is the difference between the highest and the second highest Imports (BoP, current US$) in 2006?
Make the answer very short. 4.97e+12. What is the difference between the highest and the second highest Imports (BoP, current US$) in 2007?
Make the answer very short. 5.41e+12. What is the difference between the highest and the second highest Imports (BoP, current US$) of 2008?
Keep it short and to the point. 6.06e+12. What is the difference between the highest and the lowest Imports (BoP, current US$) of 2005?
Your answer should be compact. 9.76e+12. What is the difference between the highest and the lowest Imports (BoP, current US$) in 2006?
Provide a short and direct response. 1.11e+13. What is the difference between the highest and the lowest Imports (BoP, current US$) in 2007?
Your answer should be very brief. 1.26e+13. What is the difference between the highest and the lowest Imports (BoP, current US$) of 2008?
Your response must be concise. 1.42e+13. 